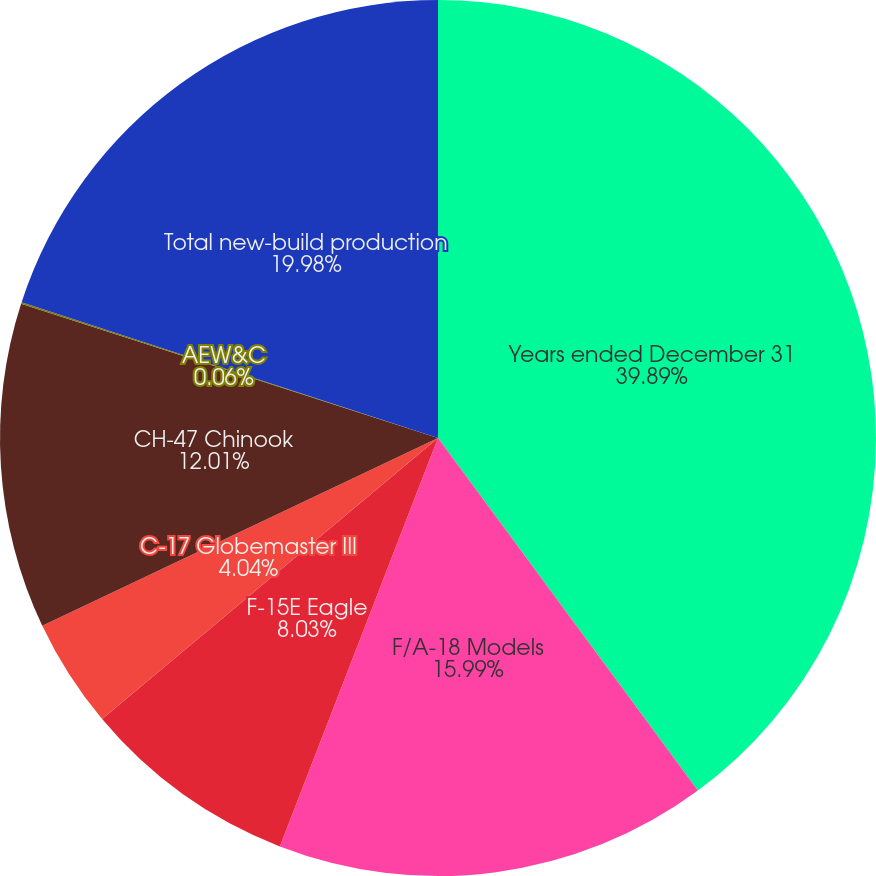Convert chart to OTSL. <chart><loc_0><loc_0><loc_500><loc_500><pie_chart><fcel>Years ended December 31<fcel>F/A-18 Models<fcel>F-15E Eagle<fcel>C-17 Globemaster III<fcel>CH-47 Chinook<fcel>AEW&C<fcel>Total new-build production<nl><fcel>39.89%<fcel>15.99%<fcel>8.03%<fcel>4.04%<fcel>12.01%<fcel>0.06%<fcel>19.98%<nl></chart> 